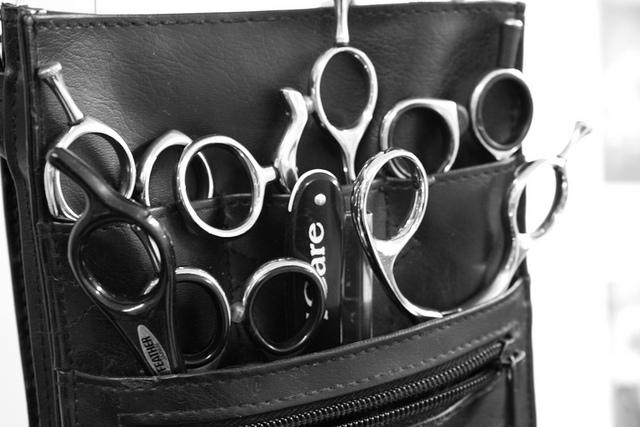What animal might the black item have come from? Please explain your reasoning. cow. Leather comes from a cow's hide. 